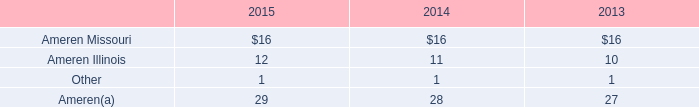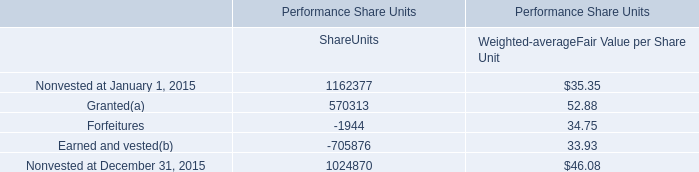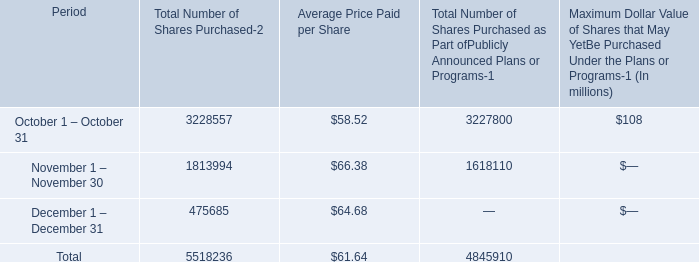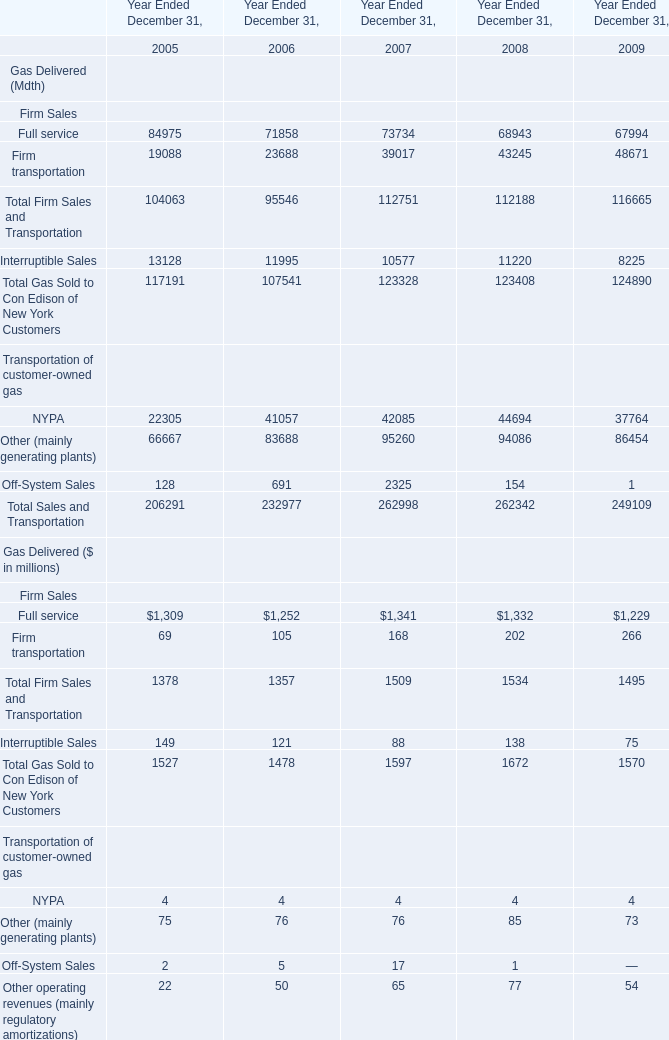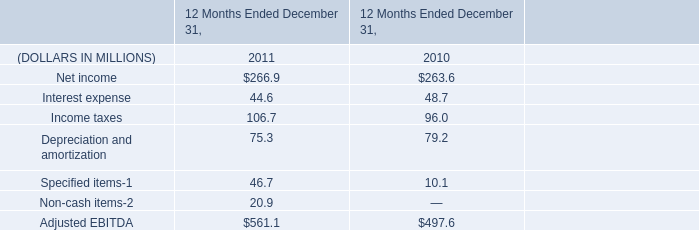What is the total amount of Interruptible Sales of Year Ended December 31, 2006, and Nonvested at December 31, 2015 of Performance Share Units ShareUnits ? 
Computations: (11995.0 + 1024870.0)
Answer: 1036865.0. 